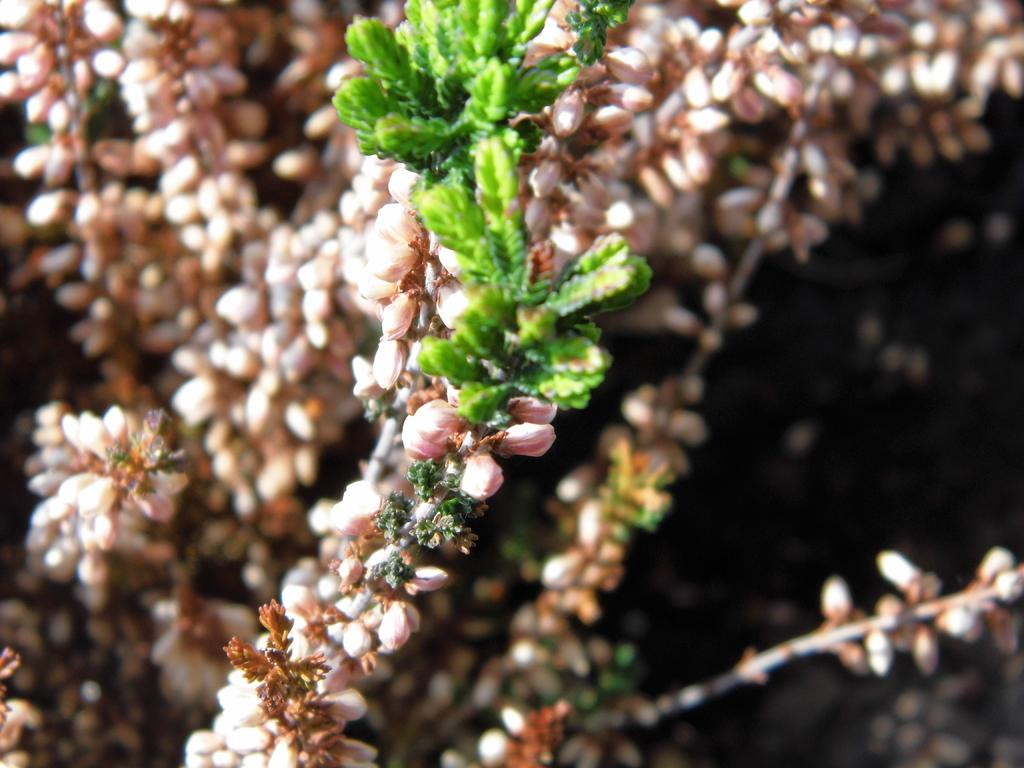What type of living organisms can be seen in the image? Plants and flowers are visible in the image. Can you describe the flowers in the image? The flowers in the image are part of the plants and add color and beauty to the scene. Are there any snails crawling on the plants in the image? There is no mention of snails in the provided facts, so we cannot determine if they are present in the image. 